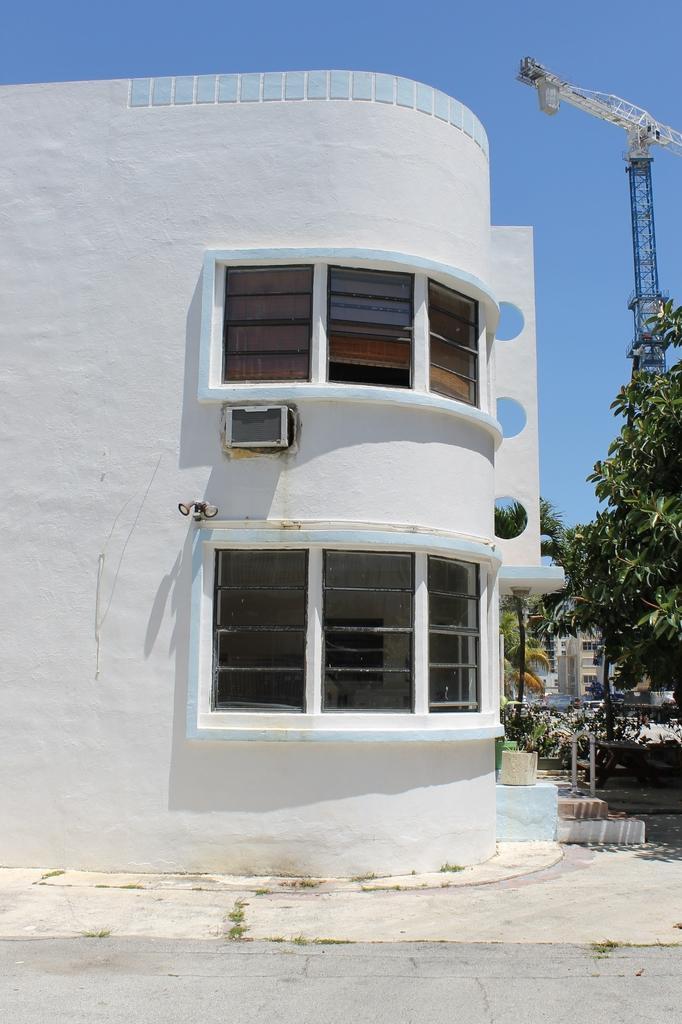Describe this image in one or two sentences. In this image, we can see buildings, trees, poles and we can see a tower. At the top, there is sky and at the bottom, there is a road. 